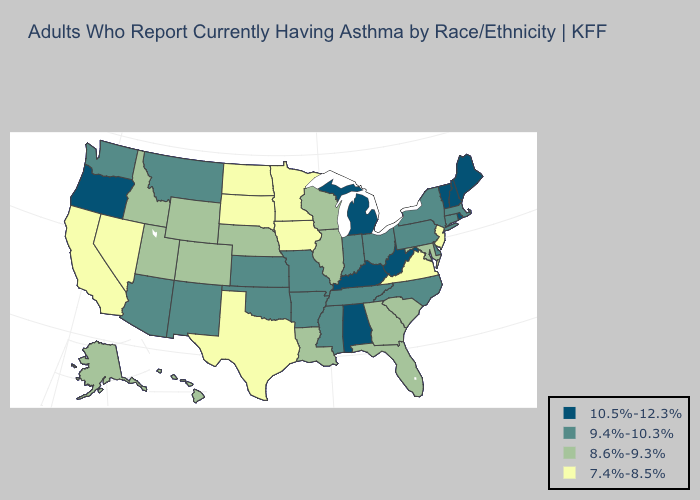What is the lowest value in the USA?
Concise answer only. 7.4%-8.5%. Among the states that border California , does Oregon have the lowest value?
Answer briefly. No. Which states have the lowest value in the USA?
Concise answer only. California, Iowa, Minnesota, Nevada, New Jersey, North Dakota, South Dakota, Texas, Virginia. Among the states that border Louisiana , which have the highest value?
Answer briefly. Arkansas, Mississippi. Name the states that have a value in the range 9.4%-10.3%?
Quick response, please. Arizona, Arkansas, Connecticut, Delaware, Indiana, Kansas, Massachusetts, Mississippi, Missouri, Montana, New Mexico, New York, North Carolina, Ohio, Oklahoma, Pennsylvania, Tennessee, Washington. Does Washington have the same value as Rhode Island?
Quick response, please. No. Does Nevada have the highest value in the West?
Concise answer only. No. What is the value of Michigan?
Short answer required. 10.5%-12.3%. What is the highest value in the Northeast ?
Quick response, please. 10.5%-12.3%. Name the states that have a value in the range 10.5%-12.3%?
Quick response, please. Alabama, Kentucky, Maine, Michigan, New Hampshire, Oregon, Rhode Island, Vermont, West Virginia. What is the value of Washington?
Give a very brief answer. 9.4%-10.3%. Among the states that border Nebraska , does Colorado have the lowest value?
Concise answer only. No. Name the states that have a value in the range 10.5%-12.3%?
Answer briefly. Alabama, Kentucky, Maine, Michigan, New Hampshire, Oregon, Rhode Island, Vermont, West Virginia. Among the states that border Vermont , does New York have the lowest value?
Answer briefly. Yes. 